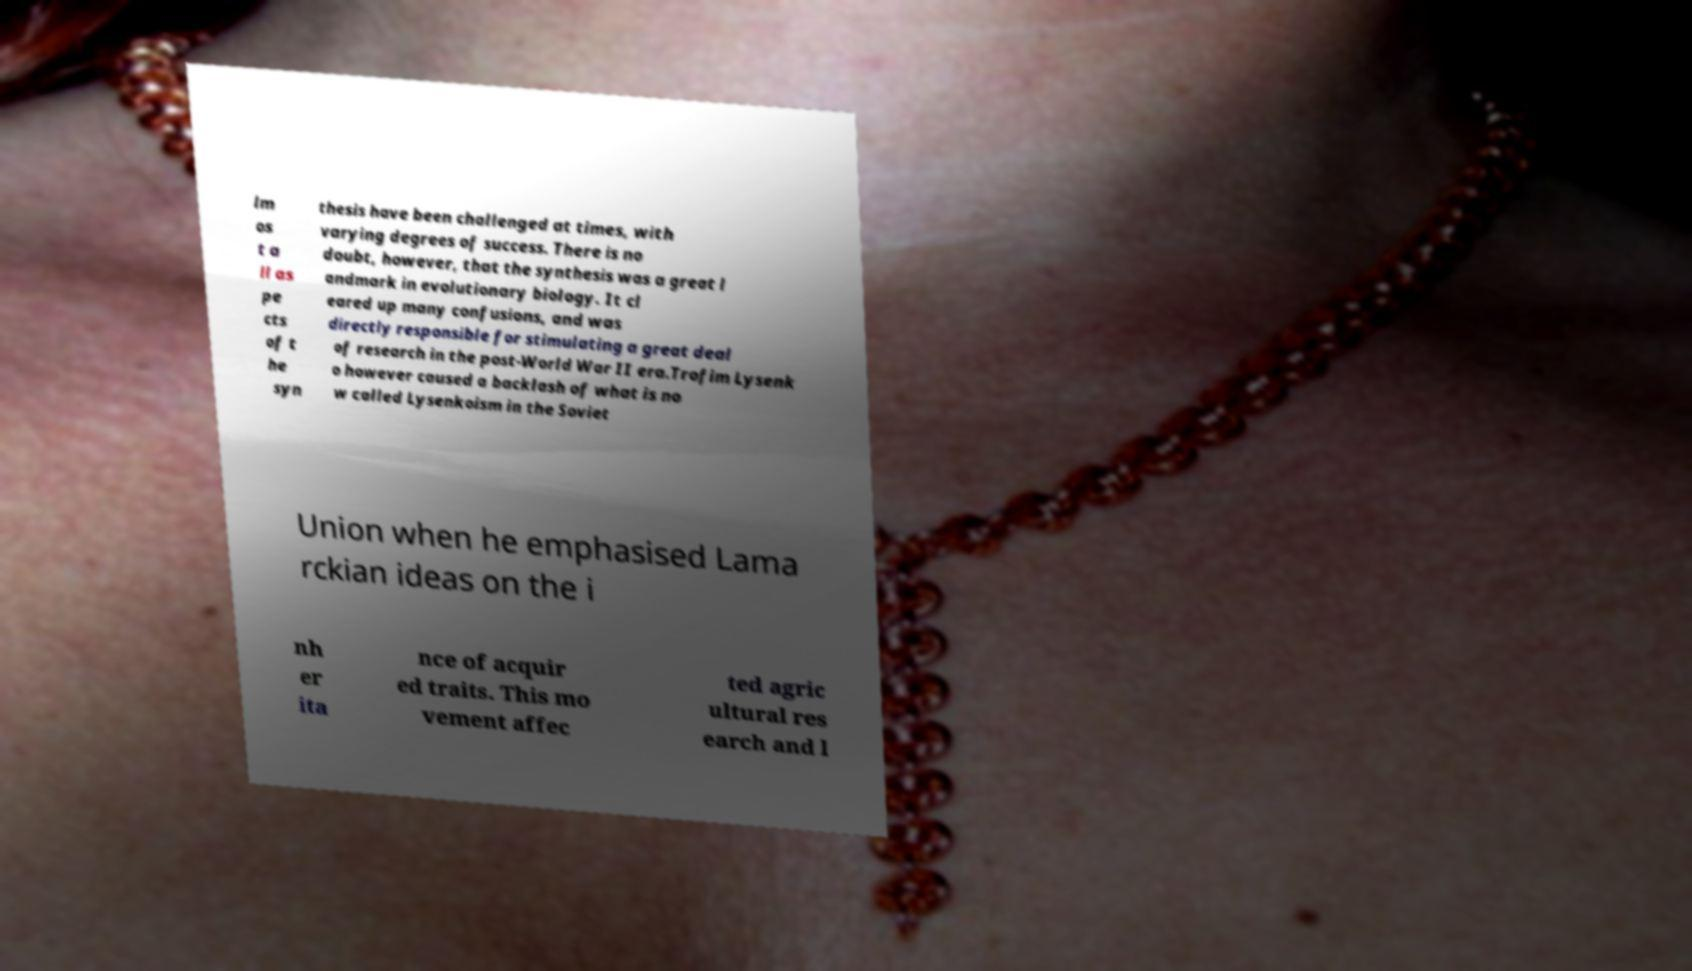Can you read and provide the text displayed in the image?This photo seems to have some interesting text. Can you extract and type it out for me? lm os t a ll as pe cts of t he syn thesis have been challenged at times, with varying degrees of success. There is no doubt, however, that the synthesis was a great l andmark in evolutionary biology. It cl eared up many confusions, and was directly responsible for stimulating a great deal of research in the post-World War II era.Trofim Lysenk o however caused a backlash of what is no w called Lysenkoism in the Soviet Union when he emphasised Lama rckian ideas on the i nh er ita nce of acquir ed traits. This mo vement affec ted agric ultural res earch and l 